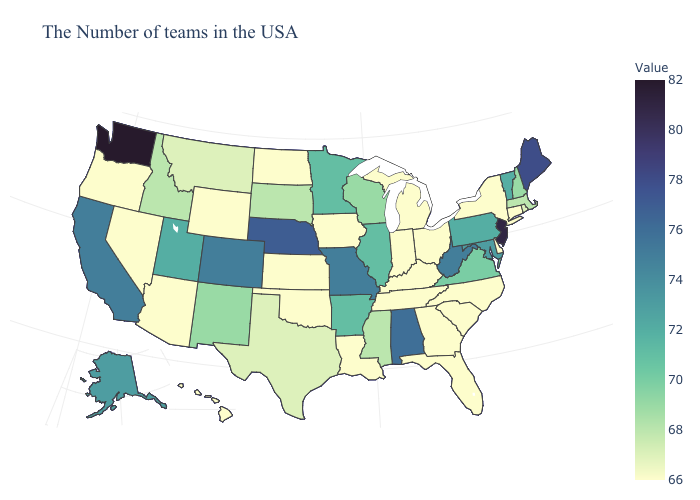Does North Dakota have the lowest value in the MidWest?
Quick response, please. Yes. Which states have the lowest value in the South?
Be succinct. Delaware, North Carolina, South Carolina, Florida, Georgia, Kentucky, Tennessee, Louisiana, Oklahoma. Among the states that border Iowa , does South Dakota have the highest value?
Answer briefly. No. Does Washington have the highest value in the USA?
Short answer required. Yes. Is the legend a continuous bar?
Write a very short answer. Yes. Which states have the highest value in the USA?
Short answer required. Washington. 